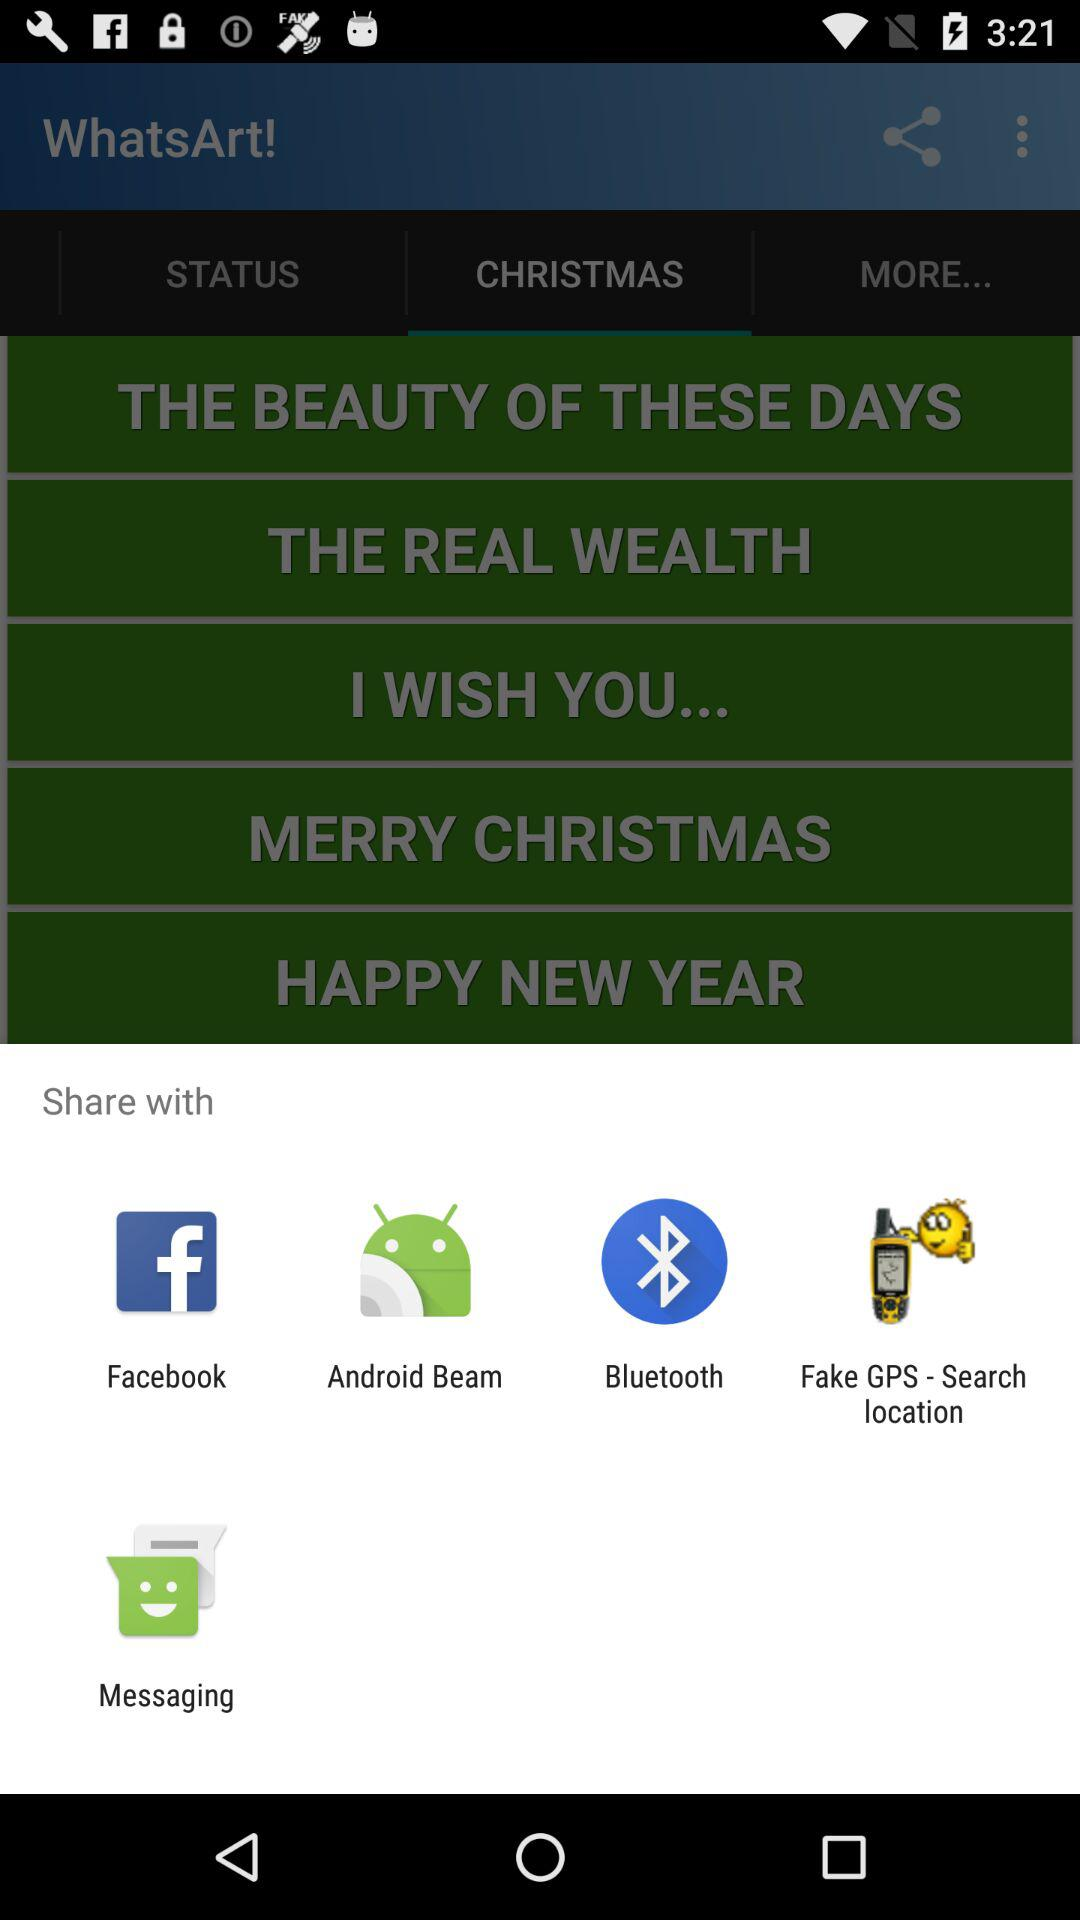Which tab is selected? The tab "CHRISTMAS" is selected. 